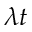<formula> <loc_0><loc_0><loc_500><loc_500>\lambda t</formula> 